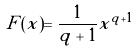Convert formula to latex. <formula><loc_0><loc_0><loc_500><loc_500>F ( x ) = { \frac { 1 } { q + 1 } } x ^ { q + 1 }</formula> 